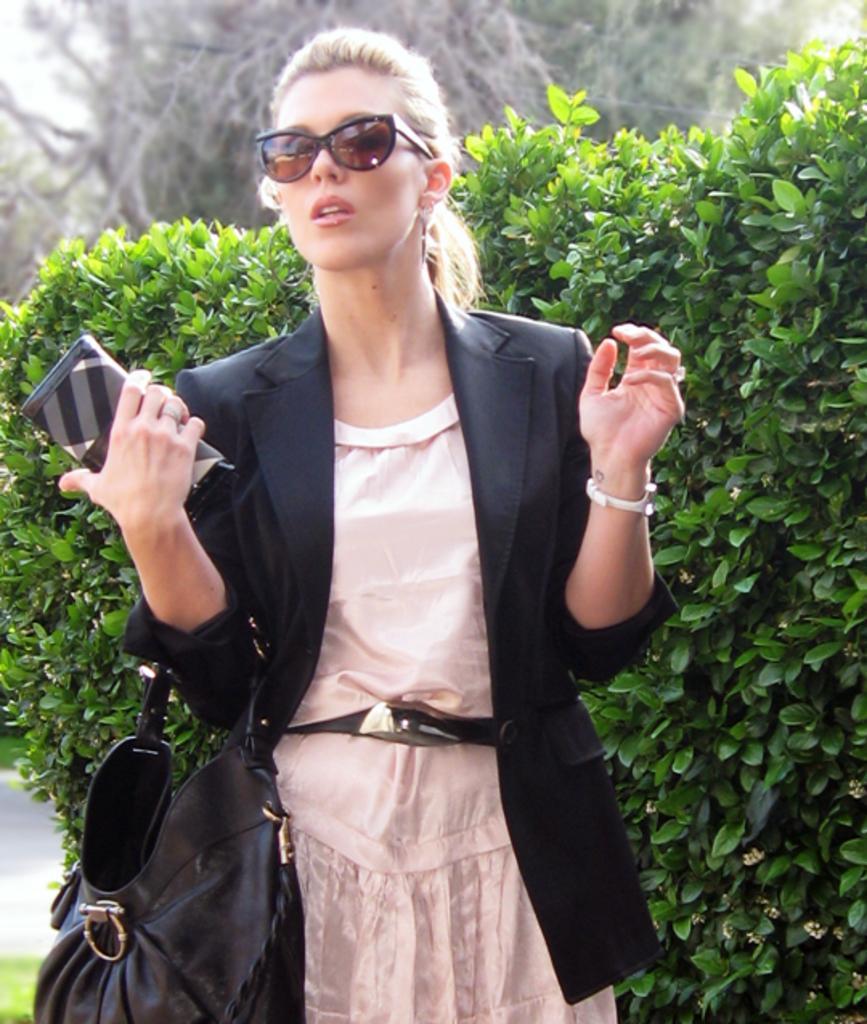In one or two sentences, can you explain what this image depicts? This image consists of a woman wearing shades and black jacket. In the background, there are plants. And she is holding a mobile. 